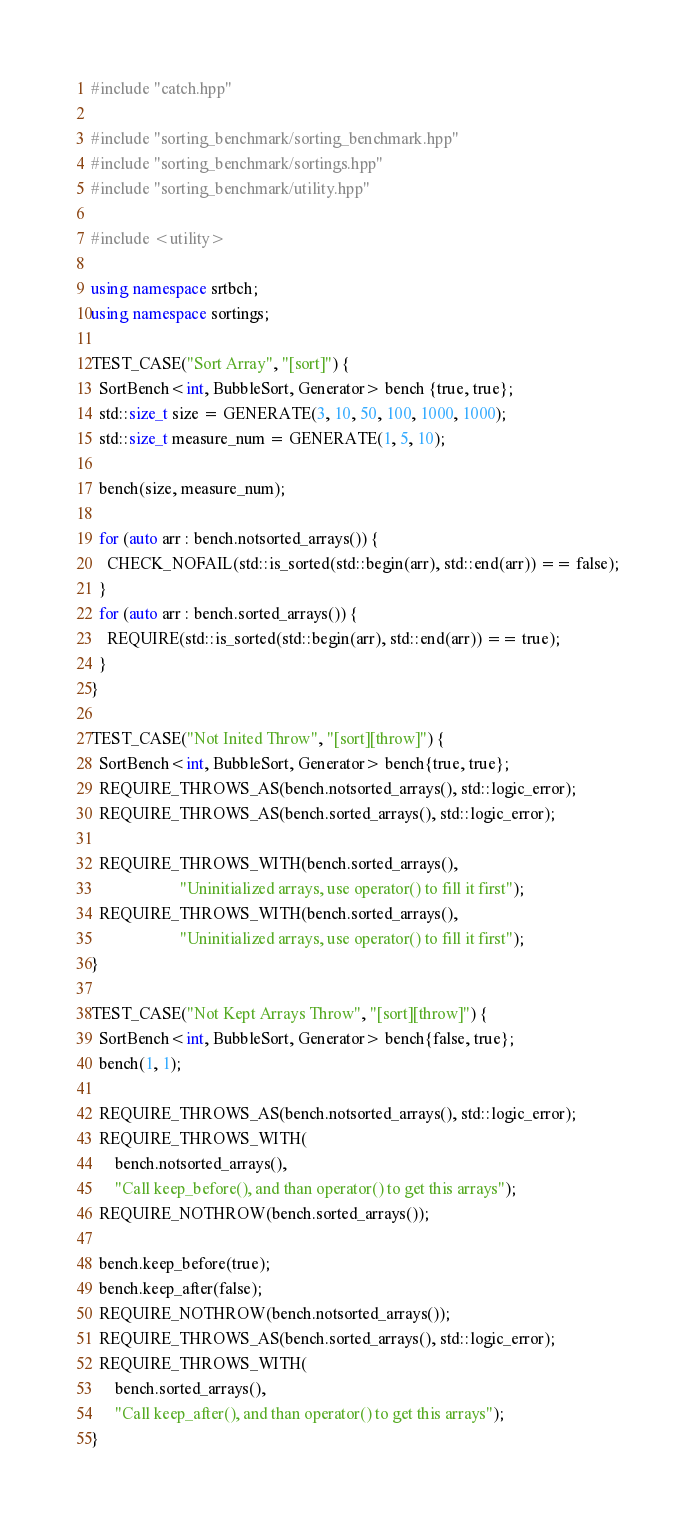<code> <loc_0><loc_0><loc_500><loc_500><_C++_>#include "catch.hpp"

#include "sorting_benchmark/sorting_benchmark.hpp"
#include "sorting_benchmark/sortings.hpp"
#include "sorting_benchmark/utility.hpp"

#include <utility>

using namespace srtbch;
using namespace sortings;

TEST_CASE("Sort Array", "[sort]") {
  SortBench<int, BubbleSort, Generator> bench {true, true};
  std::size_t size = GENERATE(3, 10, 50, 100, 1000, 1000);
  std::size_t measure_num = GENERATE(1, 5, 10);

  bench(size, measure_num);

  for (auto arr : bench.notsorted_arrays()) {
    CHECK_NOFAIL(std::is_sorted(std::begin(arr), std::end(arr)) == false);
  }
  for (auto arr : bench.sorted_arrays()) {
    REQUIRE(std::is_sorted(std::begin(arr), std::end(arr)) == true);
  }
}

TEST_CASE("Not Inited Throw", "[sort][throw]") {
  SortBench<int, BubbleSort, Generator> bench{true, true};
  REQUIRE_THROWS_AS(bench.notsorted_arrays(), std::logic_error);
  REQUIRE_THROWS_AS(bench.sorted_arrays(), std::logic_error);

  REQUIRE_THROWS_WITH(bench.sorted_arrays(),
                      "Uninitialized arrays, use operator() to fill it first");
  REQUIRE_THROWS_WITH(bench.sorted_arrays(),
                      "Uninitialized arrays, use operator() to fill it first");
}

TEST_CASE("Not Kept Arrays Throw", "[sort][throw]") {
  SortBench<int, BubbleSort, Generator> bench{false, true};
  bench(1, 1);

  REQUIRE_THROWS_AS(bench.notsorted_arrays(), std::logic_error);
  REQUIRE_THROWS_WITH(
      bench.notsorted_arrays(),
      "Call keep_before(), and than operator() to get this arrays");
  REQUIRE_NOTHROW(bench.sorted_arrays());

  bench.keep_before(true);
  bench.keep_after(false);
  REQUIRE_NOTHROW(bench.notsorted_arrays());
  REQUIRE_THROWS_AS(bench.sorted_arrays(), std::logic_error);
  REQUIRE_THROWS_WITH(
      bench.sorted_arrays(),
      "Call keep_after(), and than operator() to get this arrays");
}</code> 